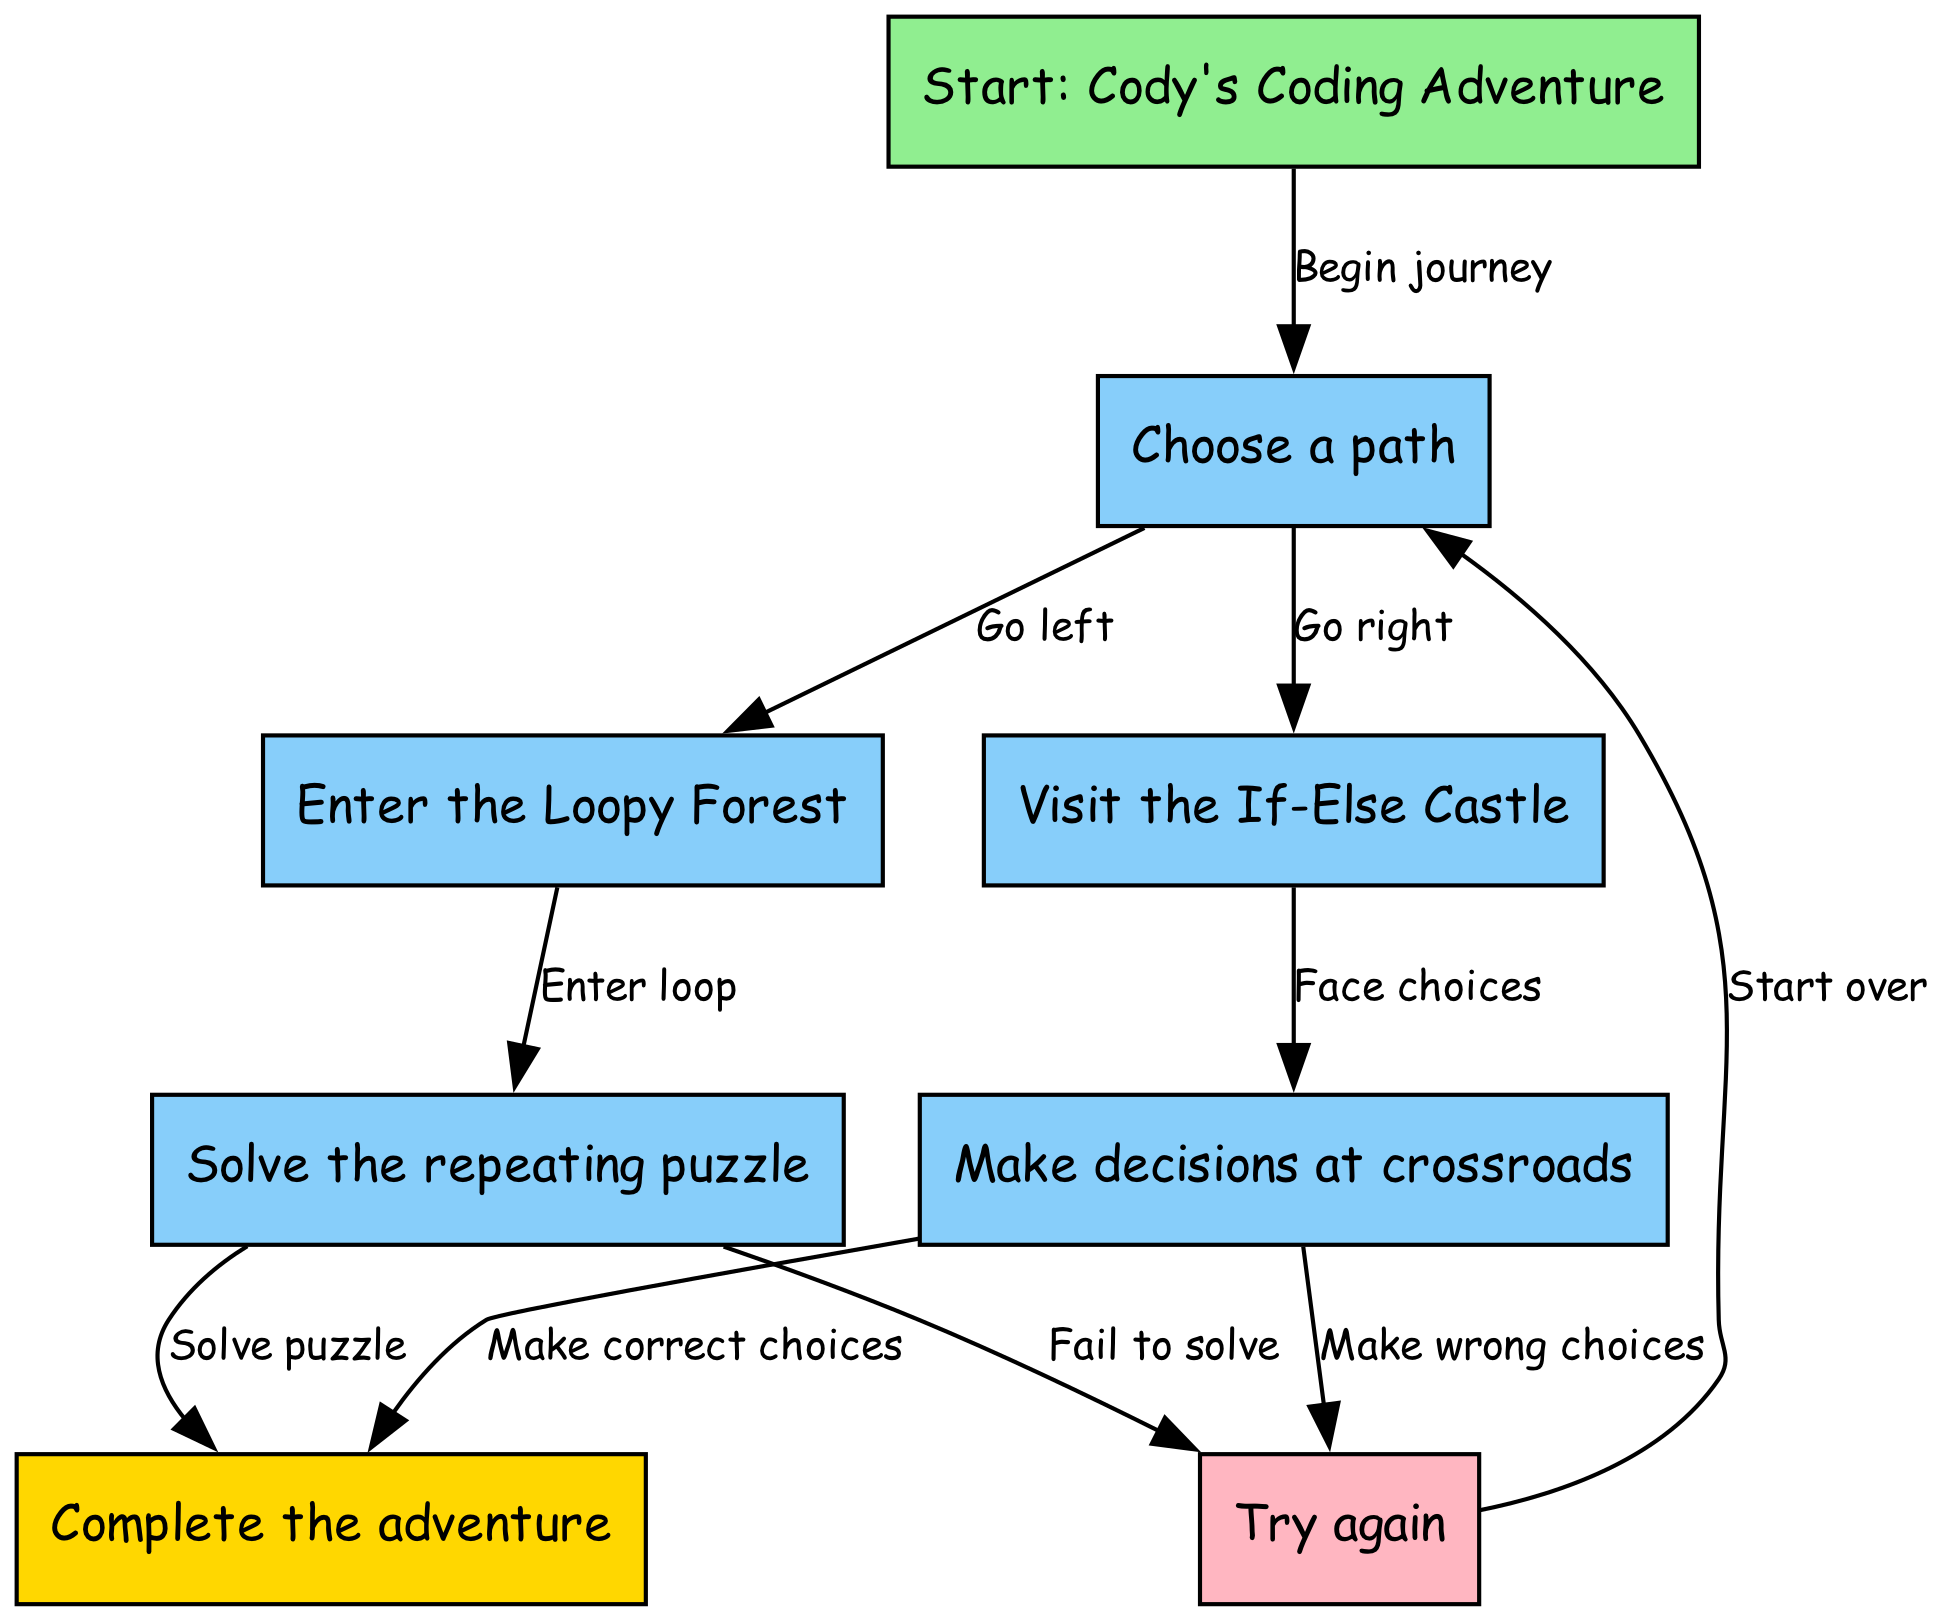What is the title of the adventure? The title node in the diagram clearly states "Start: Cody's Coding Adventure." This node establishes the beginning of the story plot.
Answer: Cody's Coding Adventure How many paths can Cody choose initially? The "Choose a path" node, which Cody encounters after starting, has two outgoing edges directing towards two choices: "Enter the Loopy Forest" and "Visit the If-Else Castle." Thus, there are two paths.
Answer: 2 What happens if Cody enters the Loopy Forest? The edge from "Loopy Forest" to "Solve the repeating puzzle" indicates that if Cody enters the Loopy Forest, he will proceed to solve a challenge.
Answer: Solve the repeating puzzle What is the outcome if Cody makes the correct choices in the If-Else Castle? According to the edge leading from "Make decisions at crossroads" to "Complete the adventure," making correct choices will allow Cody to complete his adventure successfully.
Answer: Complete the adventure How does Cody get back to the beginning if he retries? The edge connecting the "Try again" node back to "Choose a path" suggests that if Cody retries, he will start over from the path selection.
Answer: Start over What color is the success node? The diagram indicates that the "Complete the adventure" node is colored gold, distinguishing it from the other nodes.
Answer: Gold What leads to retrying in the Loopy Forest? The edge labeled "Fail to solve" indicates that if Cody cannot solve the puzzle, he will move to the "Try again" node. Thus, failing leads to a retry.
Answer: Try again How many edges are connected to the retry node? The "Try again" node has two outgoing edges: one leading back to "Choose a path," and another leading to the forest and castle challenges, indicating a total of two connections.
Answer: 2 What choice does Cody have after the forest challenge? If he solves the repeating puzzle in the forest, the edge leading from "Solve the repeating puzzle" to "Complete the adventure" means he can either succeed or retry based on further choices.
Answer: Complete the adventure 